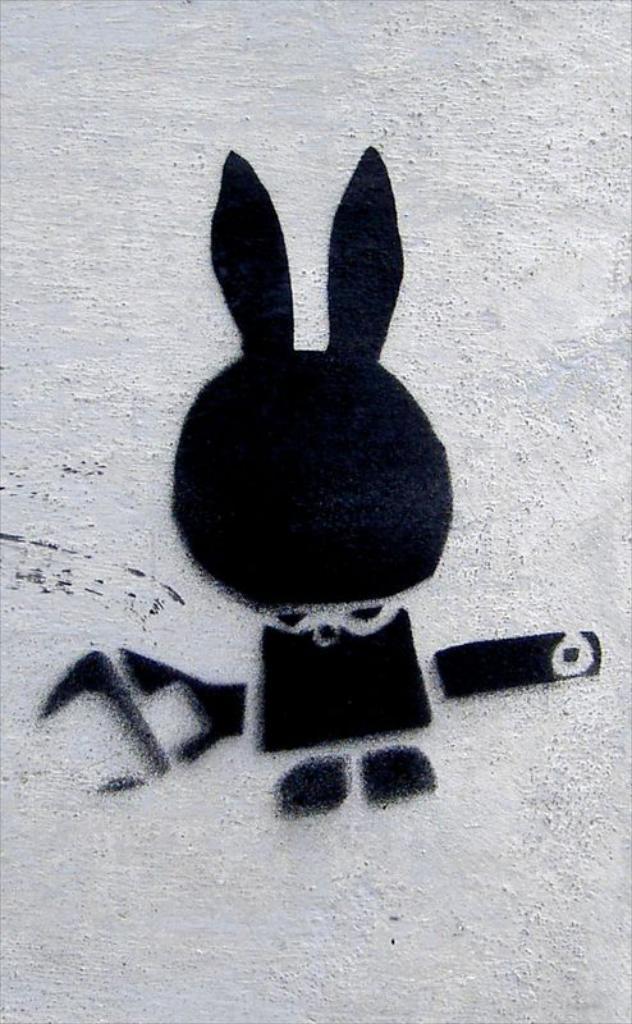In one or two sentences, can you explain what this image depicts? In the center of the image there is graffiti on the wall. 